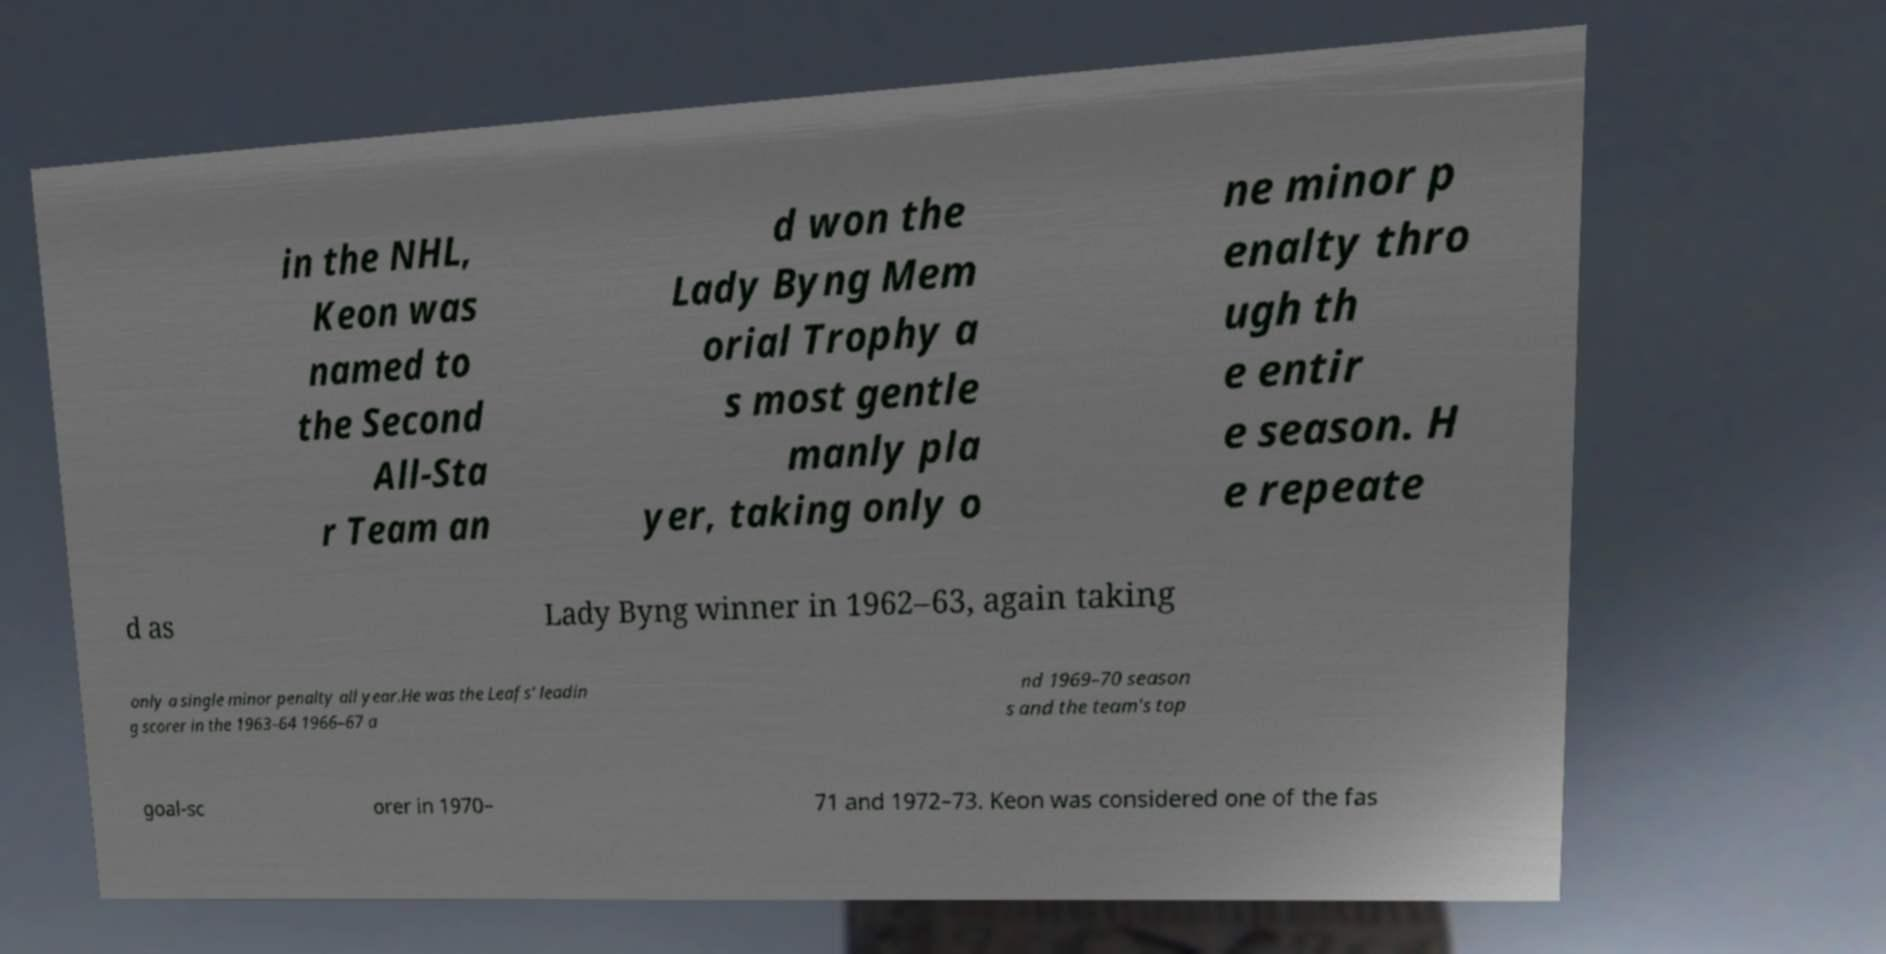I need the written content from this picture converted into text. Can you do that? in the NHL, Keon was named to the Second All-Sta r Team an d won the Lady Byng Mem orial Trophy a s most gentle manly pla yer, taking only o ne minor p enalty thro ugh th e entir e season. H e repeate d as Lady Byng winner in 1962–63, again taking only a single minor penalty all year.He was the Leafs' leadin g scorer in the 1963–64 1966–67 a nd 1969–70 season s and the team's top goal-sc orer in 1970– 71 and 1972–73. Keon was considered one of the fas 